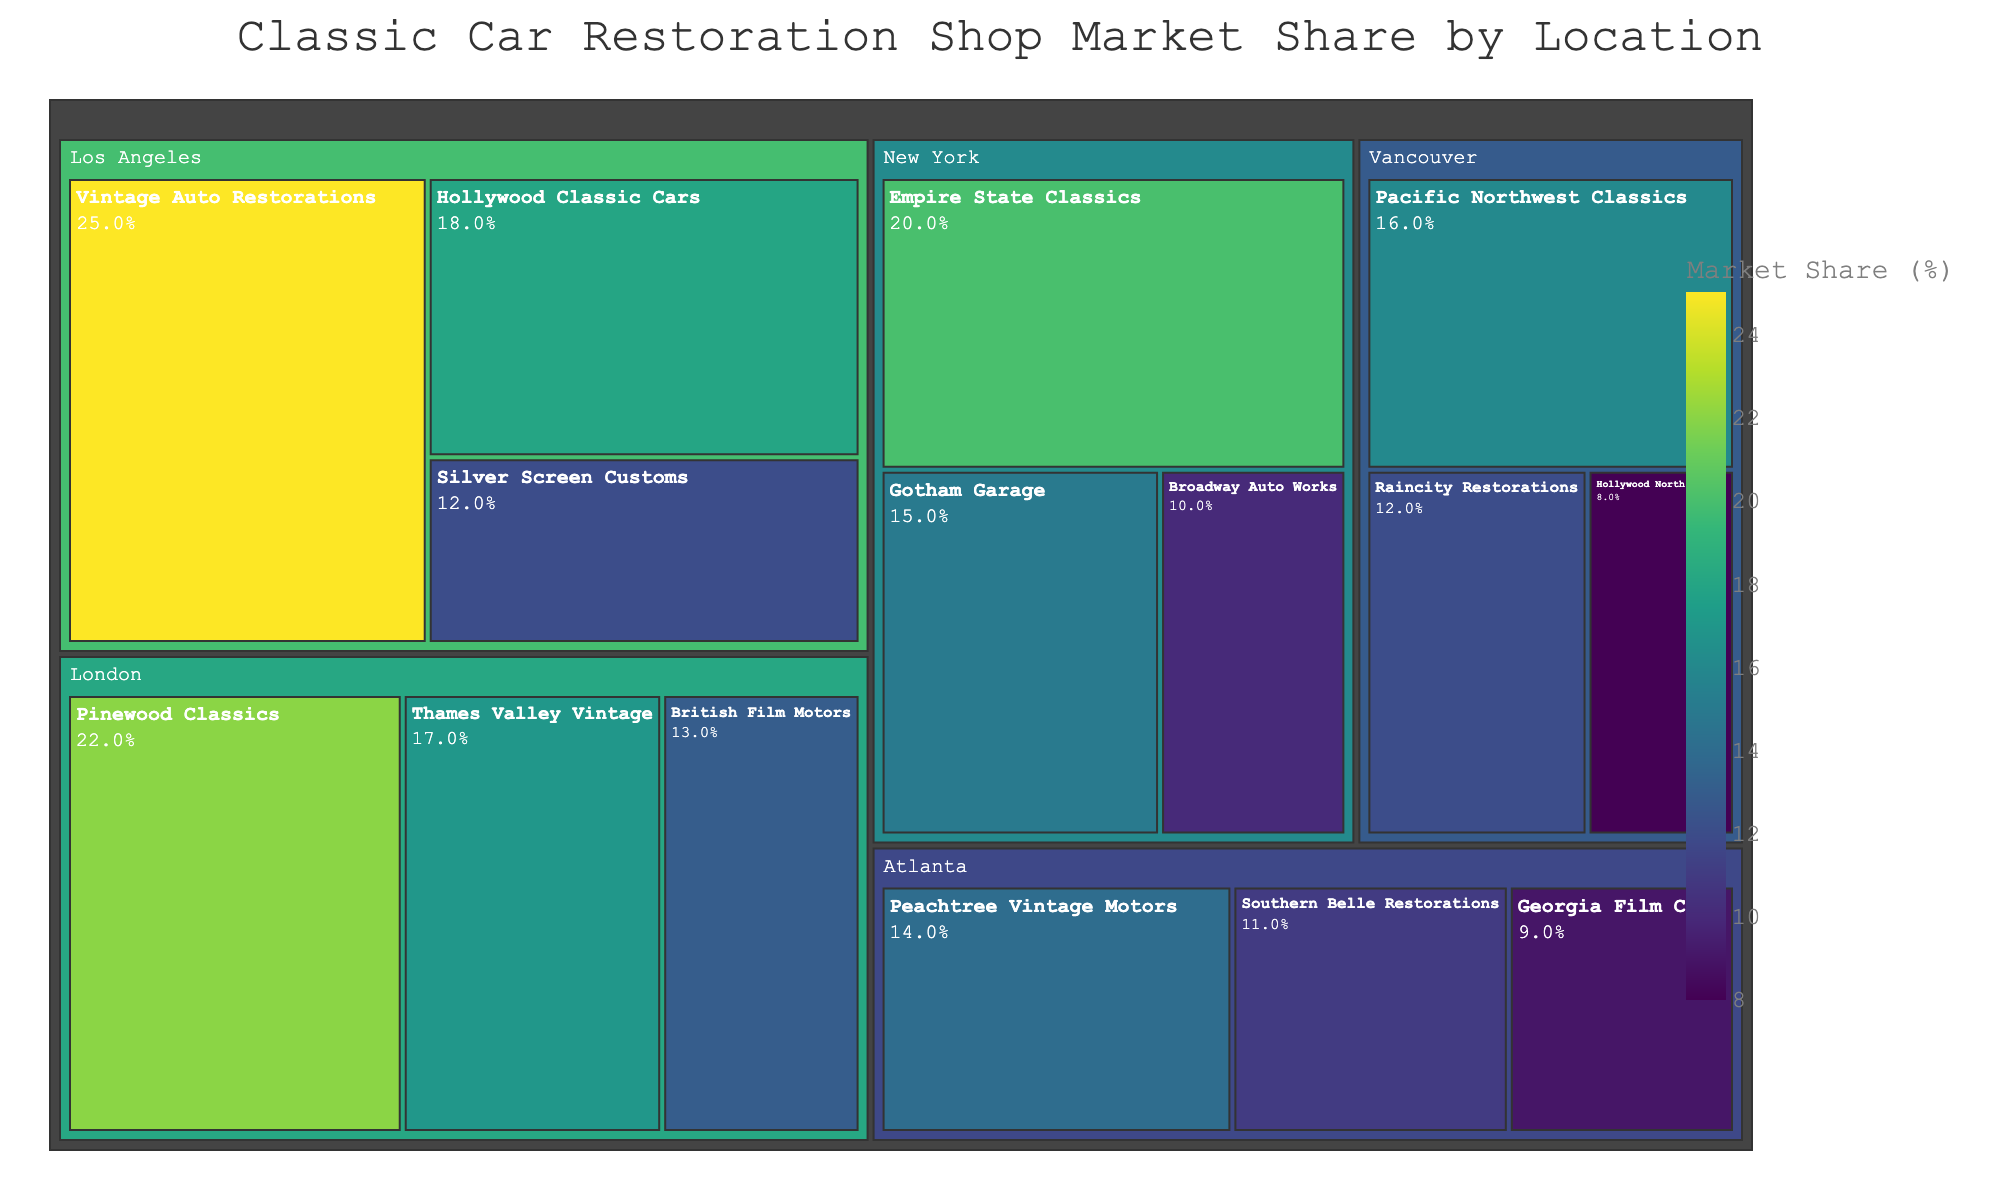What is the title of the treemap? The title of the treemap is clearly displayed at the top of the figure.
Answer: Classic Car Restoration Shop Market Share by Location Which shop has the largest market share in Los Angeles? The shop with the largest market share is the one with the biggest section in the Los Angeles area of the treemap.
Answer: Vintage Auto Restorations What is the combined market share of all shops in New York? Add the market shares of all shops in New York (Empire State Classics, Gotham Garage, Broadway Auto Works): 20 + 15 + 10 = 45
Answer: 45% Which location has the smallest cumulative market share? Compare the total market shares of shops in each location and find the smallest value.
Answer: Atlanta Compare the market share of Pinewood Classics in London to Pacific Northwest Classics in Vancouver. Which is larger? Look at the market shares for Pinewood Classics (22%) and Pacific Northwest Classics (16%) and compare them.
Answer: Pinewood Classics What is the average market share of shops in Atlanta? The average is calculated by summing the market shares of Atlanta shops (14 + 11 + 9) and dividing by the number of shops: (14 + 11 + 9) / 3 = 34 / 3 ≈ 11.33
Answer: 11.33% Which shop in Vancouver has the smallest market share? The shop with the smallest market share in Vancouver has the smallest section in the Vancouver area of the treemap.
Answer: Hollywood North Garage How many shops have a market share greater than 15%? Count the number of shops with a market share exceeding 15%: Vintage Auto Restorations (25%), Empire State Classics (20%), Pinewood Classics (22%), Thames Valley Vintage (17%), Pacific Northwest Classics (16%) make a total of 5 shops.
Answer: 5 Which location has the highest individual shop market share and what is the share? The location with the highest individual shop market share can be seen by identifying the largest single section in the entire treemap, which belongs to Vintage Auto Restorations in Los Angeles.
Answer: Los Angeles, 25% 